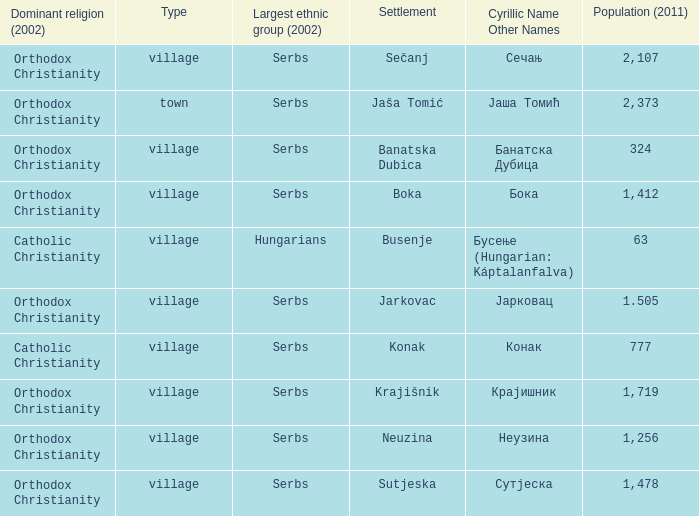What town has the population of 777? Конак. 